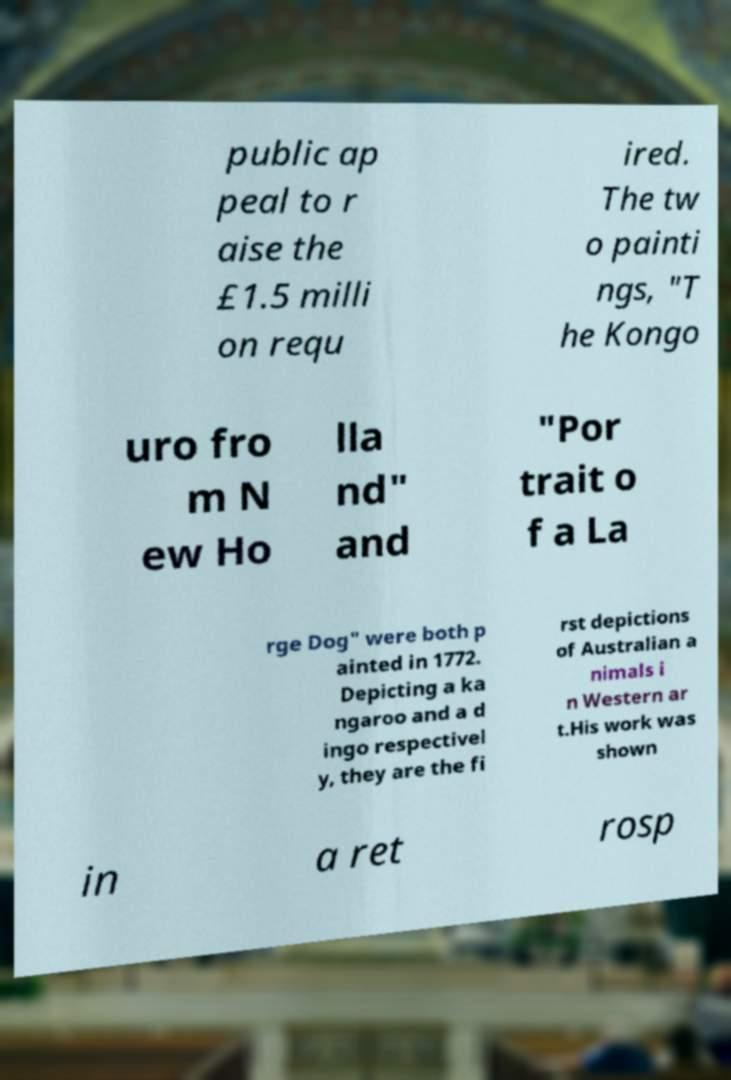Can you read and provide the text displayed in the image?This photo seems to have some interesting text. Can you extract and type it out for me? public ap peal to r aise the £1.5 milli on requ ired. The tw o painti ngs, "T he Kongo uro fro m N ew Ho lla nd" and "Por trait o f a La rge Dog" were both p ainted in 1772. Depicting a ka ngaroo and a d ingo respectivel y, they are the fi rst depictions of Australian a nimals i n Western ar t.His work was shown in a ret rosp 